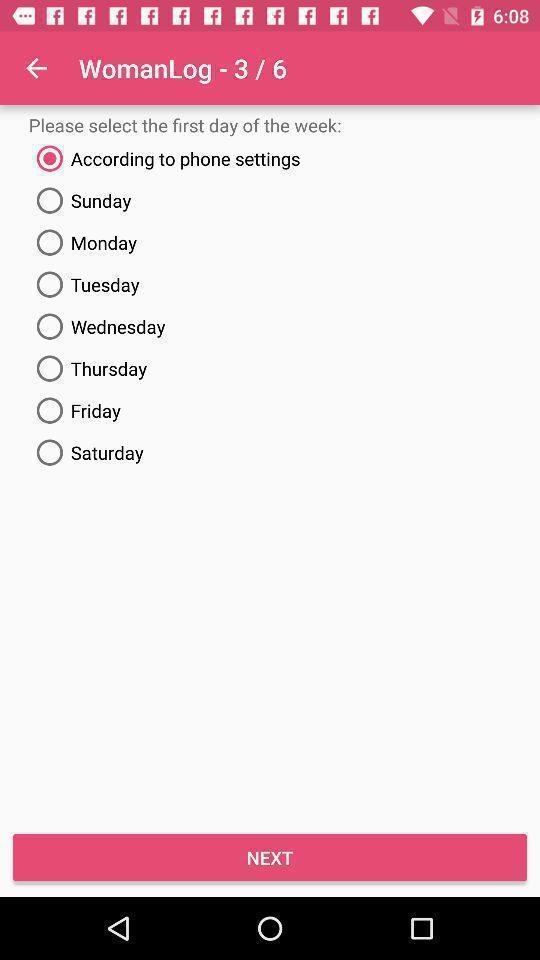Explain what's happening in this screen capture. List of various options to select. 